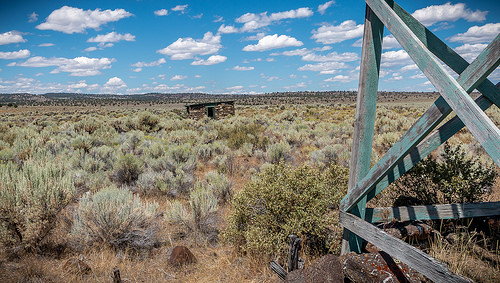<image>
Is the house next to the bush? No. The house is not positioned next to the bush. They are located in different areas of the scene. 